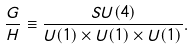<formula> <loc_0><loc_0><loc_500><loc_500>\frac { G } { H } \equiv \frac { S U ( 4 ) } { U ( 1 ) \times U ( 1 ) \times U ( 1 ) } .</formula> 